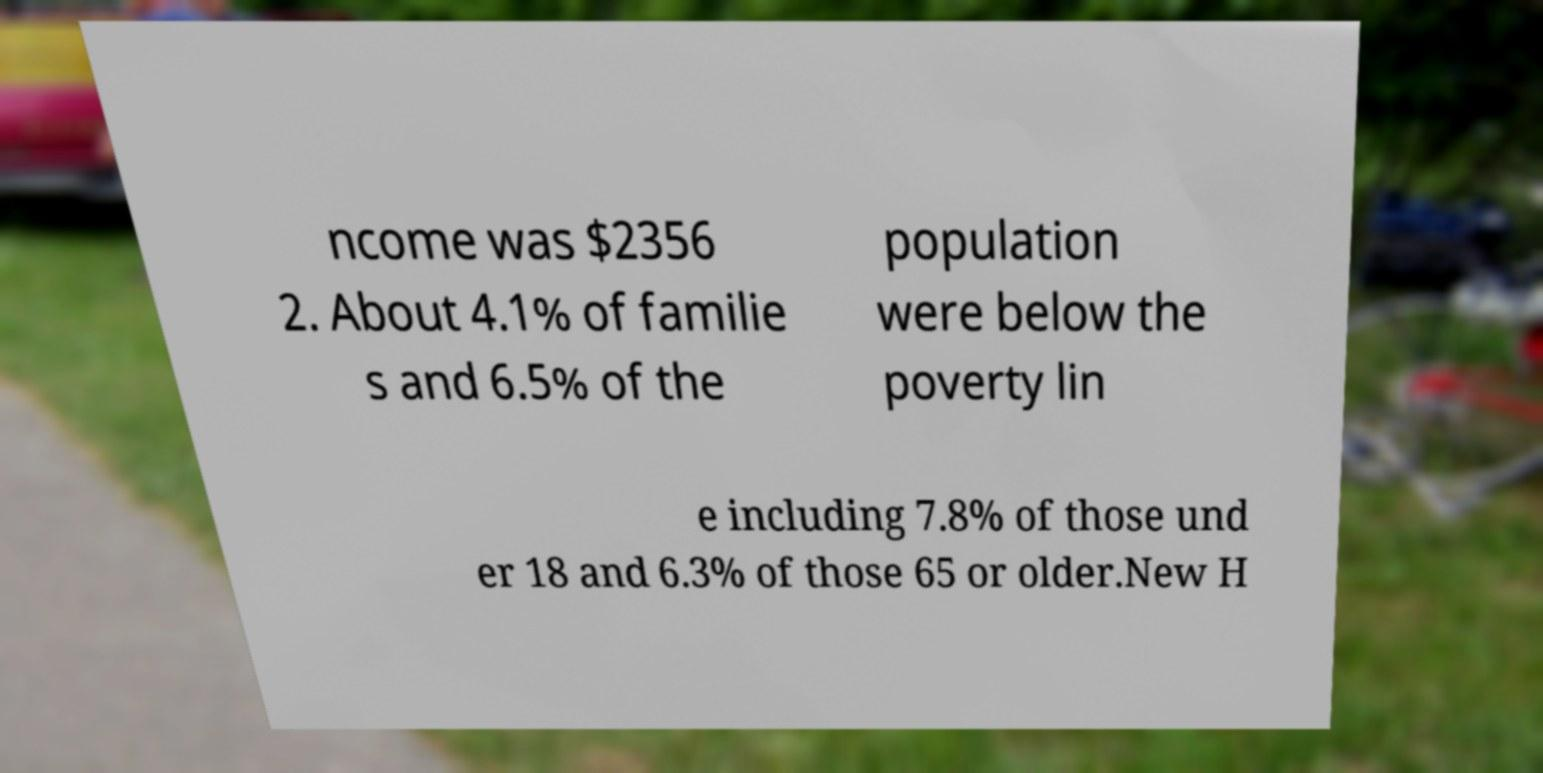What messages or text are displayed in this image? I need them in a readable, typed format. ncome was $2356 2. About 4.1% of familie s and 6.5% of the population were below the poverty lin e including 7.8% of those und er 18 and 6.3% of those 65 or older.New H 